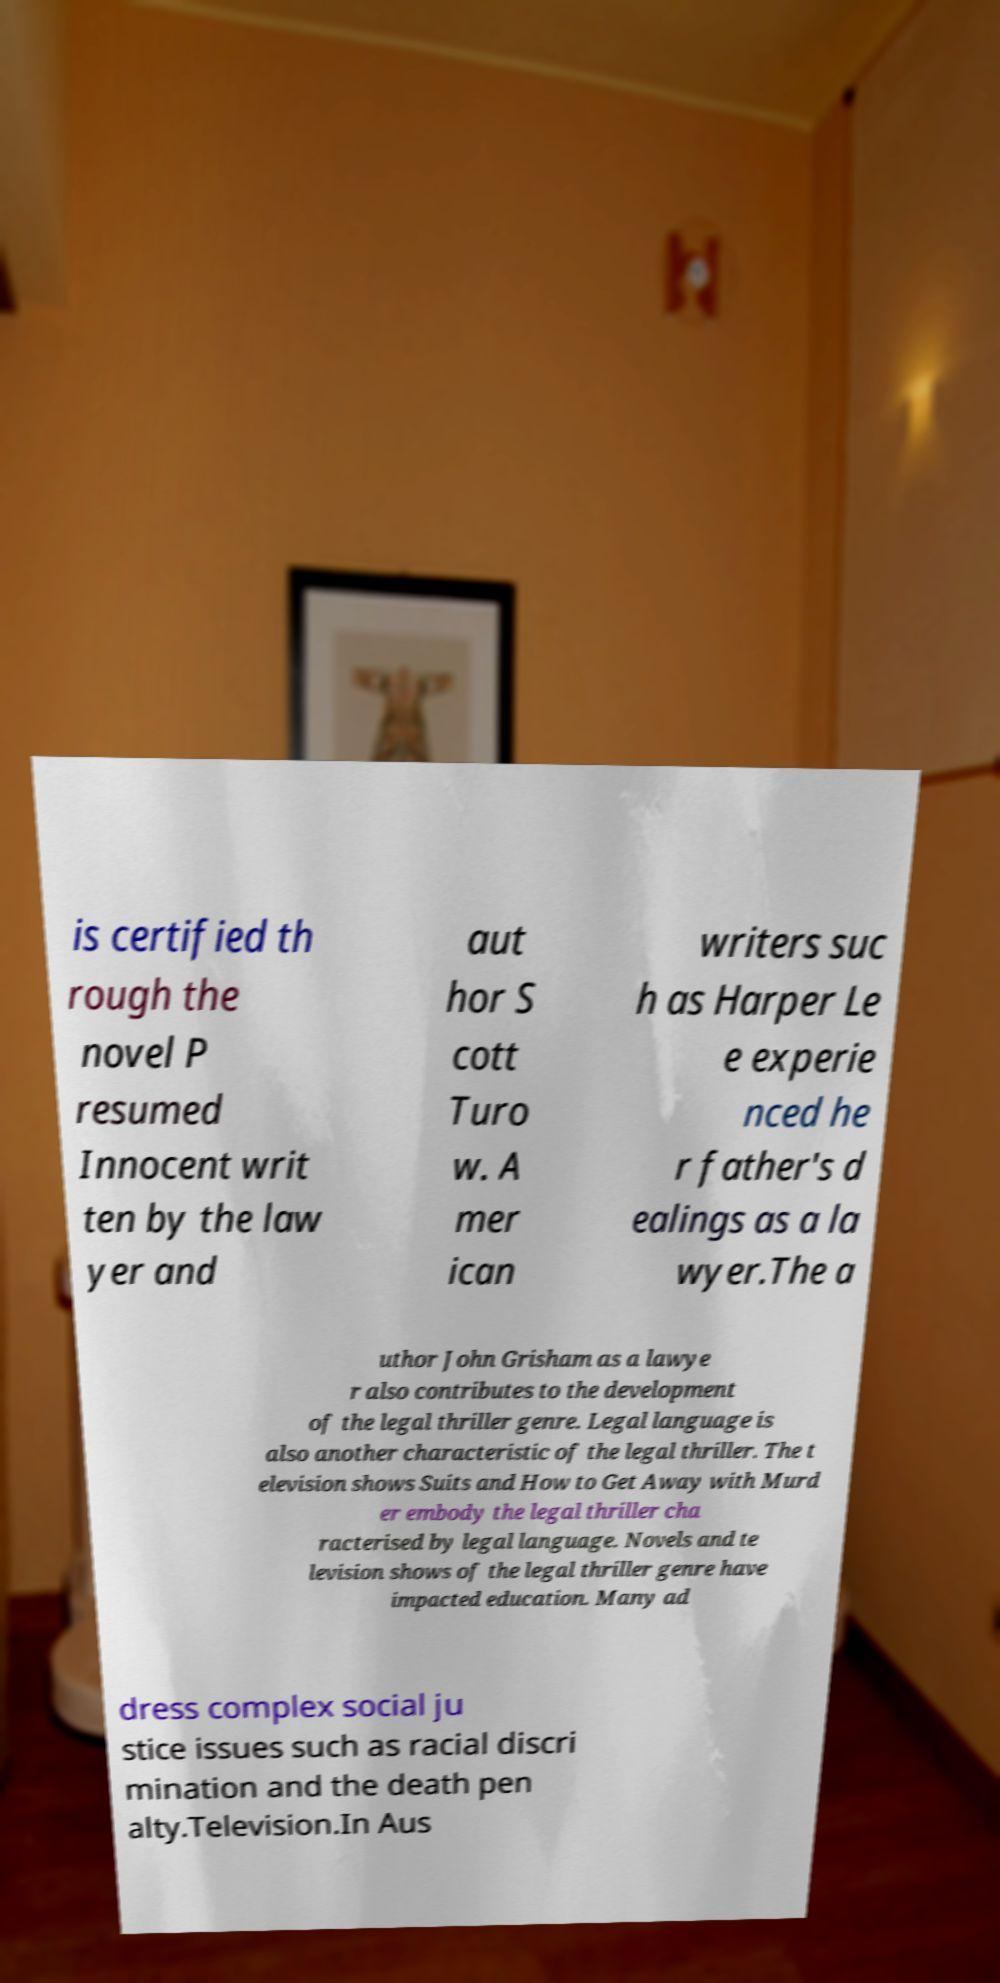Please identify and transcribe the text found in this image. is certified th rough the novel P resumed Innocent writ ten by the law yer and aut hor S cott Turo w. A mer ican writers suc h as Harper Le e experie nced he r father's d ealings as a la wyer.The a uthor John Grisham as a lawye r also contributes to the development of the legal thriller genre. Legal language is also another characteristic of the legal thriller. The t elevision shows Suits and How to Get Away with Murd er embody the legal thriller cha racterised by legal language. Novels and te levision shows of the legal thriller genre have impacted education. Many ad dress complex social ju stice issues such as racial discri mination and the death pen alty.Television.In Aus 